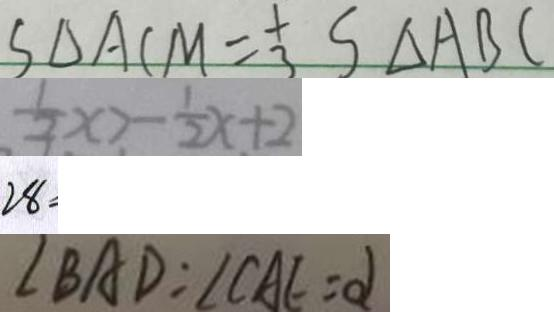<formula> <loc_0><loc_0><loc_500><loc_500>S _ { \Delta A C M } = \frac { 1 } { 3 } S _ { \Delta A B C } 
 \frac { 1 } { 3 } x > - \frac { 1 } { 2 } x + 2 
 2 8 
 \angle B A D = \angle C A E = \alpha</formula> 